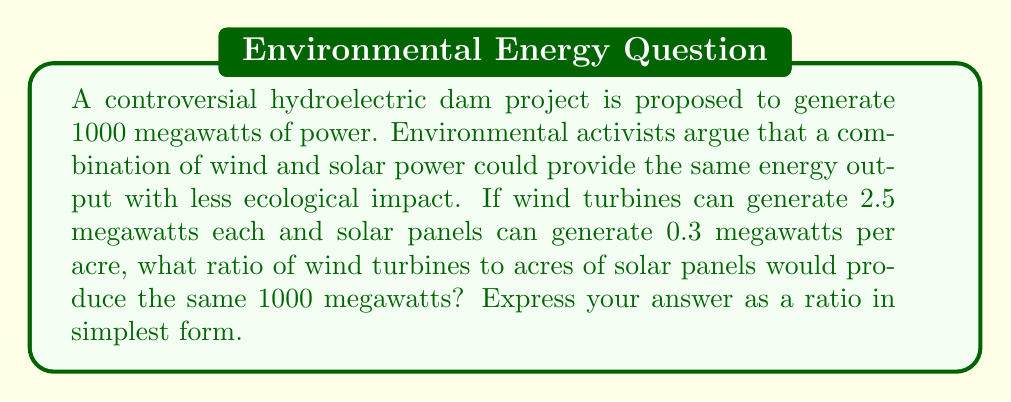Help me with this question. Let's approach this step-by-step:

1) Let $x$ be the number of wind turbines and $y$ be the acres of solar panels.

2) We can set up an equation based on the total power output:

   $2.5x + 0.3y = 1000$

3) To find a ratio, we need to express $x$ in terms of $y$:

   $2.5x = 1000 - 0.3y$
   $x = 400 - 0.12y$

4) Now, we have a ratio of $x:y = (400 - 0.12y) : y$

5) To simplify this, let's multiply both sides by 25 to eliminate decimals:

   $25x : 25y = (10000 - 3y) : 25y$

6) Simplify:

   $25x : 25y = (10000 - 3y) : 25y = 400 : 1$

This means for every 400 wind turbines, we need 1 acre of solar panels to achieve the same power output as the dam.
Answer: $400:1$ 